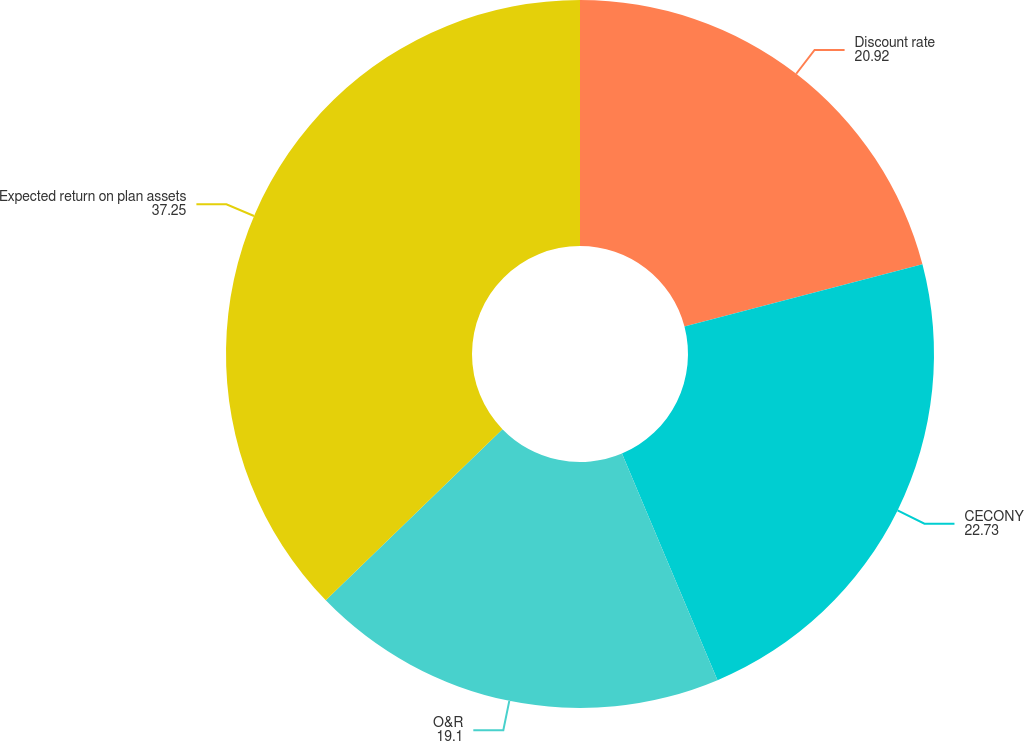<chart> <loc_0><loc_0><loc_500><loc_500><pie_chart><fcel>Discount rate<fcel>CECONY<fcel>O&R<fcel>Expected return on plan assets<nl><fcel>20.92%<fcel>22.73%<fcel>19.1%<fcel>37.25%<nl></chart> 